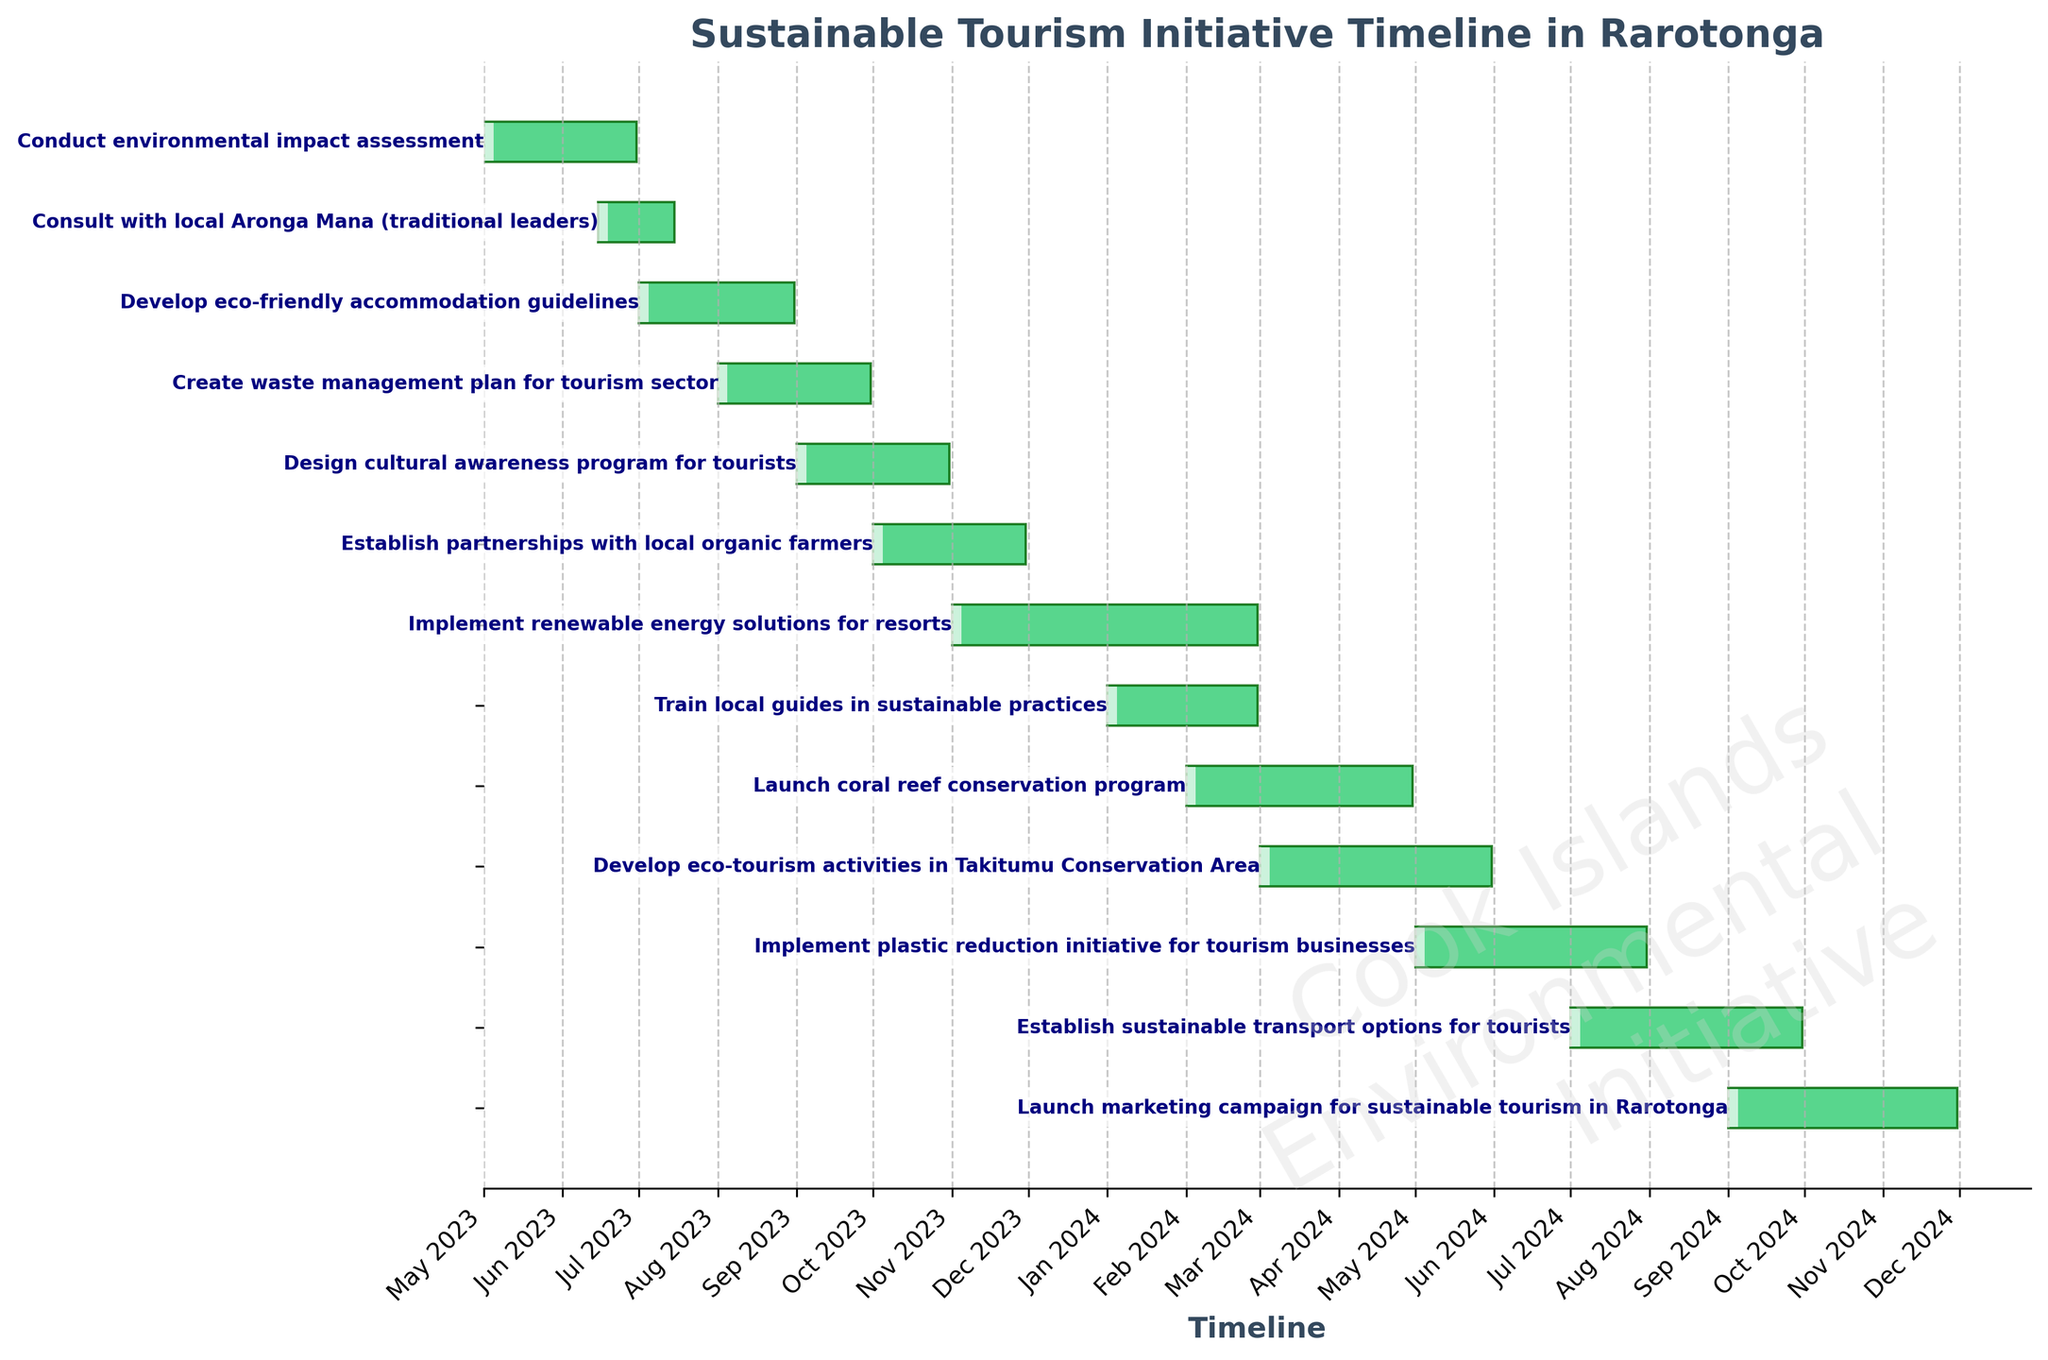Which task starts in May 2023? The task starting in May 2023 is labeled at the top of the Gantt Chart. By following the timeline, "Conduct environmental impact assessment" starts in May 2023.
Answer: Conduct environmental impact assessment How many tasks are scheduled to start in 2023? By counting the starting months from the beginning of the timeline in the figure, identify that 7 tasks are scheduled to start within the year 2023.
Answer: 7 How long does the "Create waste management plan for tourism sector" task take? Locate the task on the Gantt Chart and measure its length along the timeline. It starts in August 2023 and ends in September 2023, covering 2 months.
Answer: 2 months Which task ends at the same time "Consult with local Aronga Mana (traditional leaders)" starts? Find the exact point where the "Consult with local Aronga Mana (traditional leaders)" starts on the Gantt Chart, June 2023. The "Conduct environmental impact assessment" also ends in June 2023.
Answer: Conduct environmental impact assessment Between "Develop eco-friendly accommodation guidelines" and "Create waste management plan for tourism sector," which one starts first? Identifying both tasks on the timeline shows "Develop eco-friendly accommodation guidelines" starts in July 2023 before "Create waste management plan for tourism sector" in August 2023.
Answer: Develop eco-friendly accommodation guidelines Do any tasks overlap in November 2023? By examining the timeline for November 2023, "Establish partnerships with local organic farmers" and "Implement renewable energy solutions for resorts" overlap during that month.
Answer: Yes What is the final task on the Gantt Chart? The last task on the timeline labeled at the bottom is "Launch marketing campaign for sustainable tourism in Rarotonga," and it ends in November 2024.
Answer: Launch marketing campaign for sustainable tourism in Rarotonga 